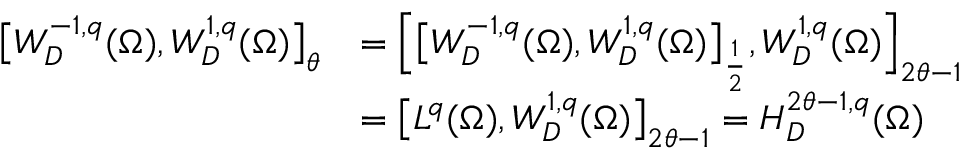Convert formula to latex. <formula><loc_0><loc_0><loc_500><loc_500>\begin{array} { r l } { \left [ W _ { D } ^ { - 1 , q } ( \Omega ) , W _ { D } ^ { 1 , q } ( \Omega ) \right ] _ { \theta } } & { = \left [ \left [ W _ { D } ^ { - 1 , q } ( \Omega ) , W _ { D } ^ { 1 , q } ( \Omega ) \right ] _ { \frac { 1 } { 2 } } , W _ { D } ^ { 1 , q } ( \Omega ) \right ] _ { 2 \theta - 1 } } \\ & { = \left [ L ^ { q } ( \Omega ) , W _ { D } ^ { 1 , q } ( \Omega ) \right ] _ { 2 \theta - 1 } = H _ { D } ^ { 2 \theta - 1 , q } ( \Omega ) } \end{array}</formula> 